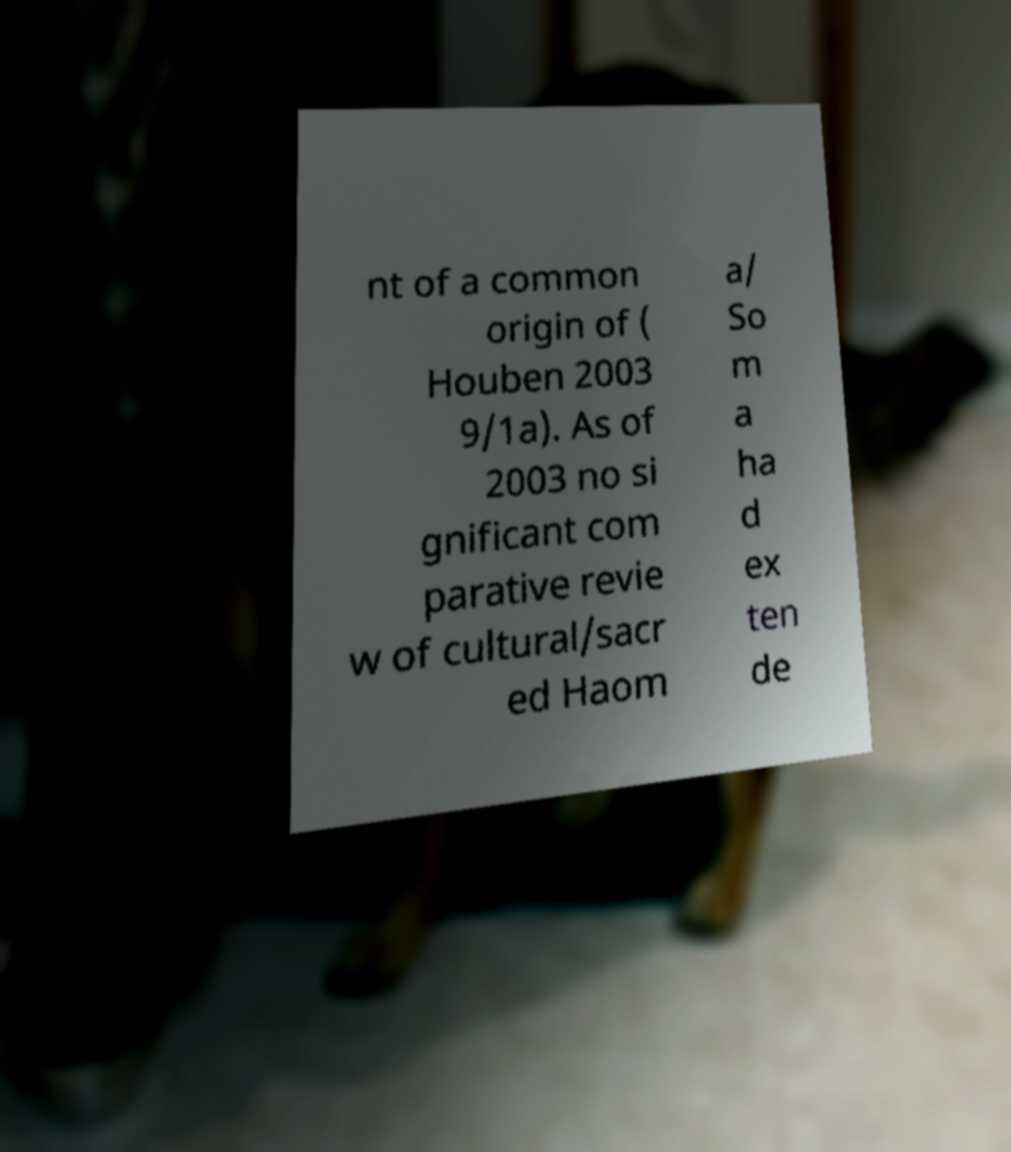Please read and relay the text visible in this image. What does it say? nt of a common origin of ( Houben 2003 9/1a). As of 2003 no si gnificant com parative revie w of cultural/sacr ed Haom a/ So m a ha d ex ten de 